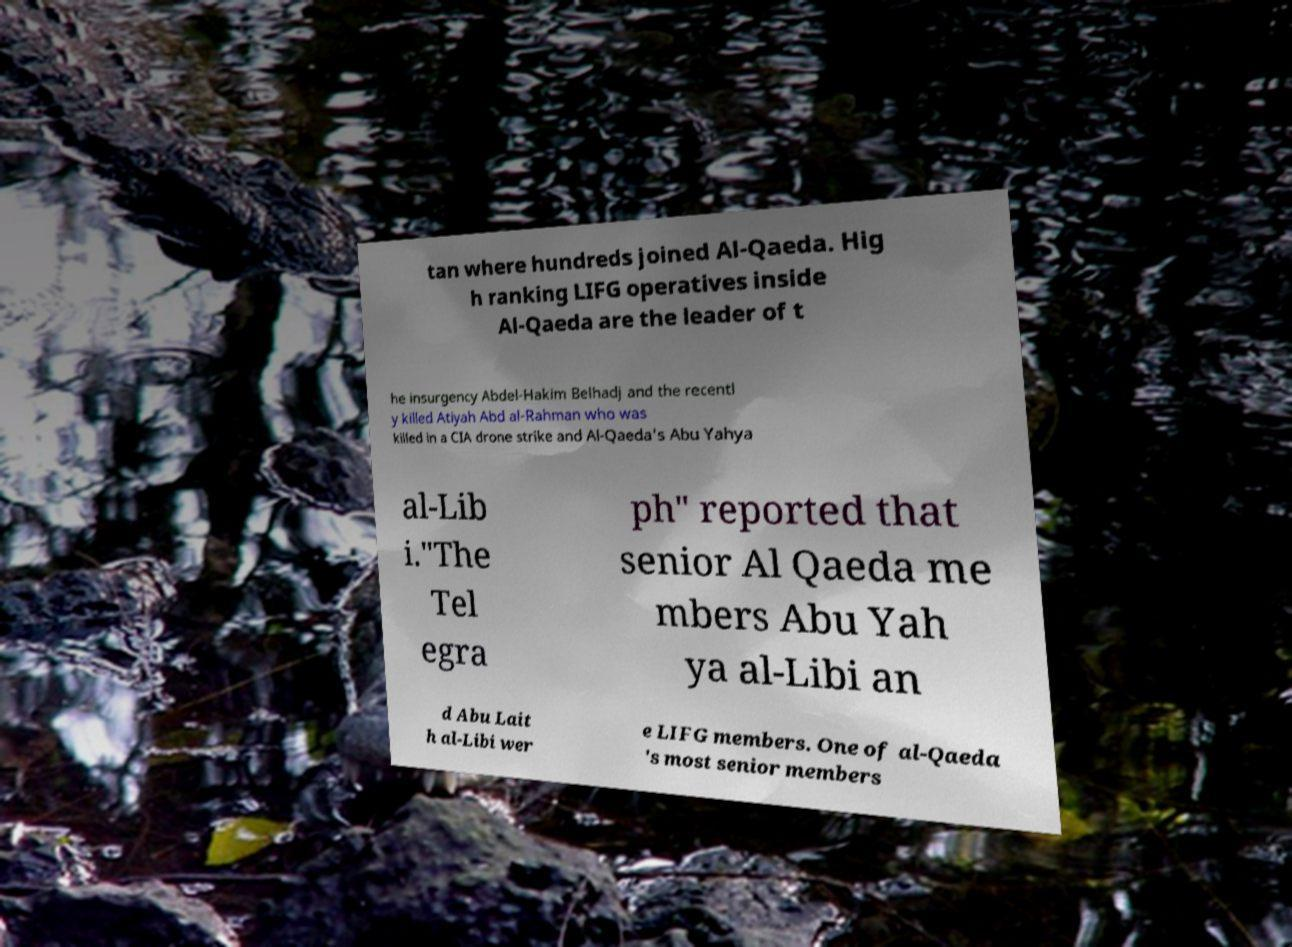Please identify and transcribe the text found in this image. tan where hundreds joined Al-Qaeda. Hig h ranking LIFG operatives inside Al-Qaeda are the leader of t he insurgency Abdel-Hakim Belhadj and the recentl y killed Atiyah Abd al-Rahman who was killed in a CIA drone strike and Al-Qaeda's Abu Yahya al-Lib i."The Tel egra ph" reported that senior Al Qaeda me mbers Abu Yah ya al-Libi an d Abu Lait h al-Libi wer e LIFG members. One of al-Qaeda 's most senior members 